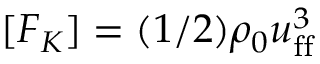<formula> <loc_0><loc_0><loc_500><loc_500>[ F _ { K } ] = ( 1 / 2 ) \rho _ { 0 } u _ { f f } ^ { 3 }</formula> 